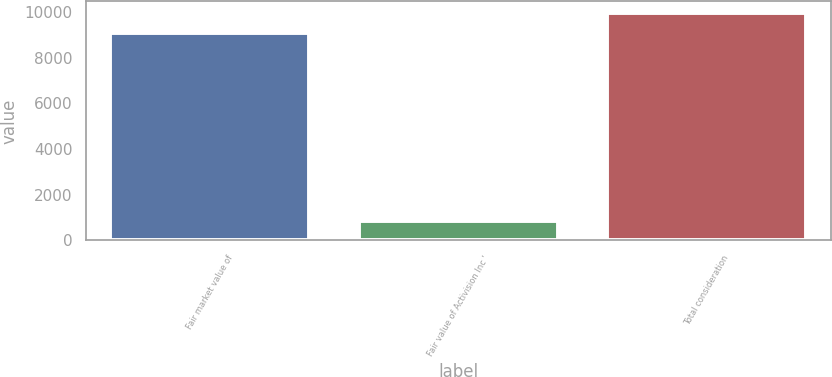<chart> <loc_0><loc_0><loc_500><loc_500><bar_chart><fcel>Fair market value of<fcel>Fair value of Activision Inc '<fcel>Total consideration<nl><fcel>9057<fcel>861<fcel>9962.8<nl></chart> 